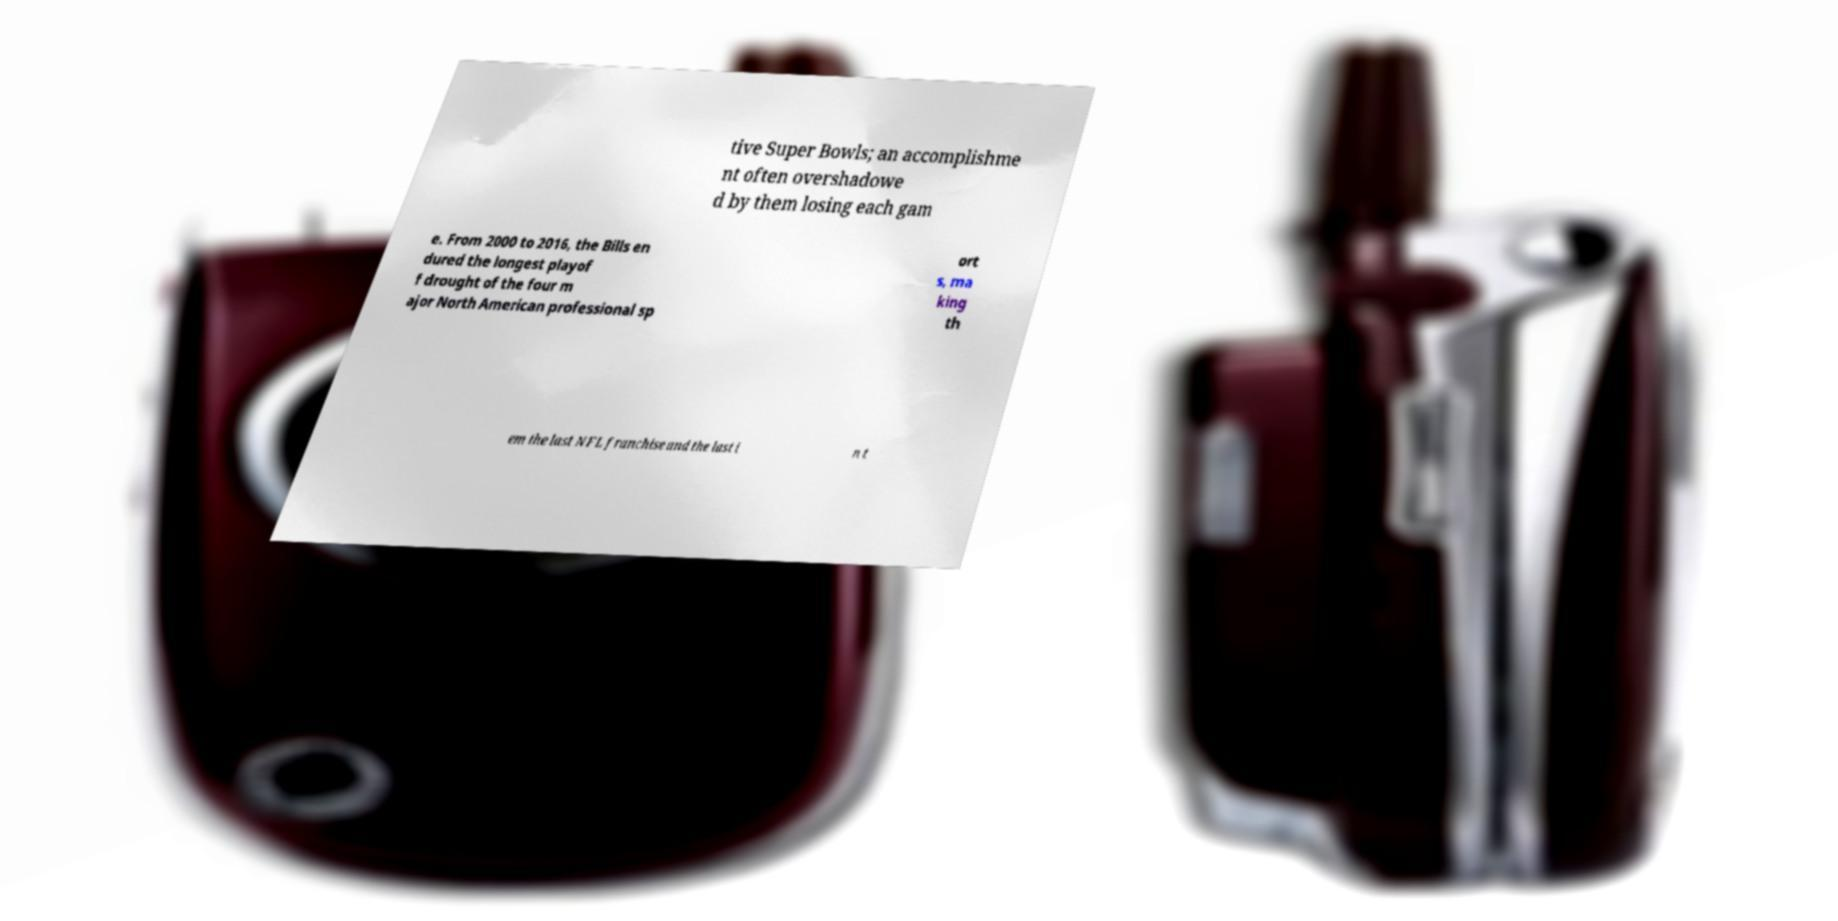I need the written content from this picture converted into text. Can you do that? tive Super Bowls; an accomplishme nt often overshadowe d by them losing each gam e. From 2000 to 2016, the Bills en dured the longest playof f drought of the four m ajor North American professional sp ort s, ma king th em the last NFL franchise and the last i n t 